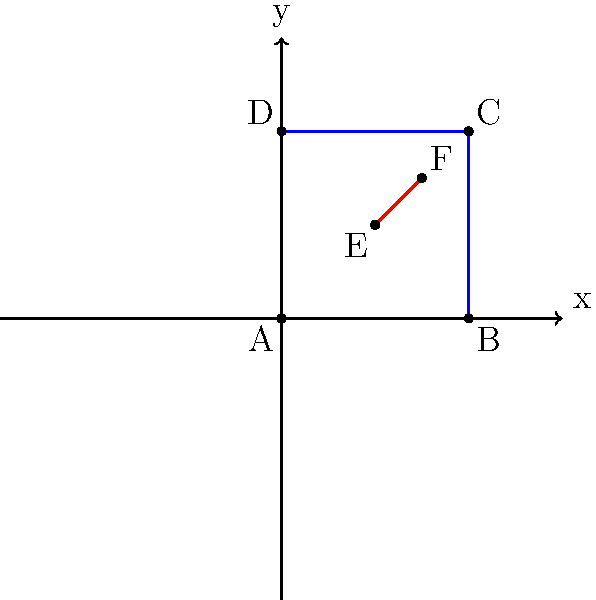In the diagram above, a blue square ABCD and a red line segment EF are shown on a coordinate plane. If this shape is reflected first across the y-axis and then across the x-axis, what will be the coordinates of point F after both reflections? Express your answer as an ordered pair. To solve this problem, we'll follow these steps:

1. Identify the original coordinates of point F:
   From the diagram, we can see that F is at (1.5, 1.5).

2. Reflect across the y-axis:
   - When reflecting across the y-axis, the x-coordinate changes sign, while the y-coordinate remains the same.
   - F(1.5, 1.5) becomes F'(-1.5, 1.5)

3. Reflect the result across the x-axis:
   - When reflecting across the x-axis, the y-coordinate changes sign, while the x-coordinate remains the same.
   - F'(-1.5, 1.5) becomes F''(-1.5, -1.5)

4. Express the final coordinates as an ordered pair:
   The final position of F after both reflections is (-1.5, -1.5).

This problem demonstrates how multiple reflections can be combined to transform a shape, which is an important concept in layout design and image manipulation for publishing.
Answer: $(-1.5, -1.5)$ 